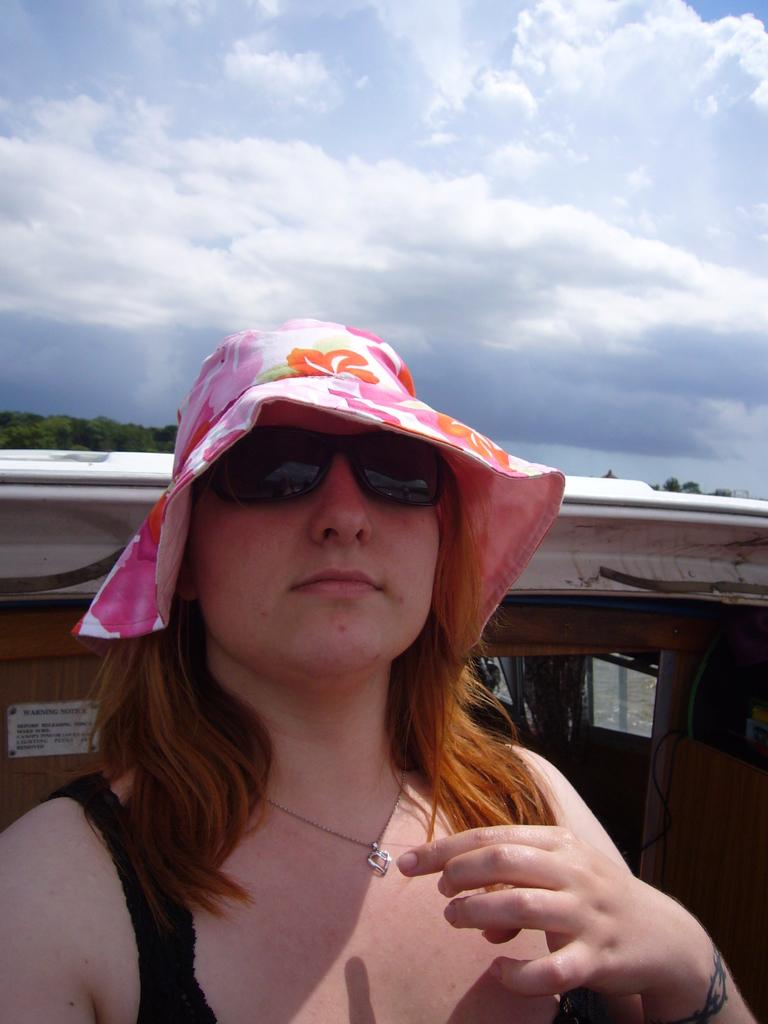Who is present in the image? There is a woman in the image. What is the woman wearing on her head? The woman is wearing a pink cap. What accessory is the woman wearing on her face? The woman is wearing spectacles. What can be seen in the background of the image? There is a vehicle and the sky visible in the image. What is the condition of the sky in the image? Clouds are present in the sky. How many brothers does the woman have in the image? There is no information about the woman's brothers in the image. What type of stocking is the woman wearing in the image? There is no mention of stockings in the image; the woman is wearing spectacles and a pink cap. 